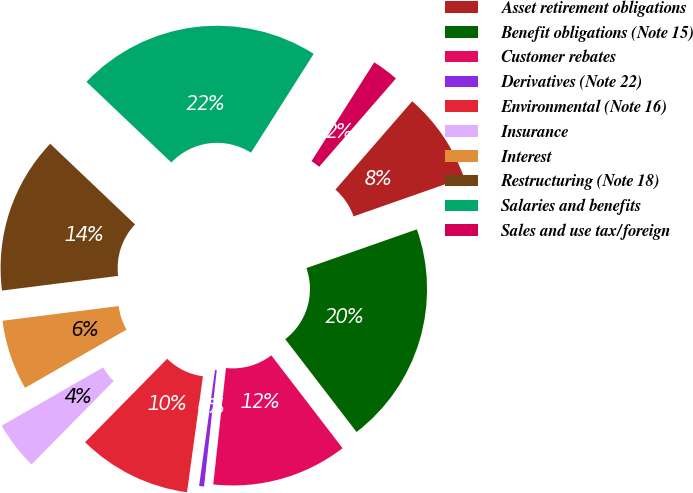Convert chart. <chart><loc_0><loc_0><loc_500><loc_500><pie_chart><fcel>Asset retirement obligations<fcel>Benefit obligations (Note 15)<fcel>Customer rebates<fcel>Derivatives (Note 22)<fcel>Environmental (Note 16)<fcel>Insurance<fcel>Interest<fcel>Restructuring (Note 18)<fcel>Salaries and benefits<fcel>Sales and use tax/foreign<nl><fcel>8.24%<fcel>19.95%<fcel>12.15%<fcel>0.44%<fcel>10.2%<fcel>4.34%<fcel>6.29%<fcel>14.1%<fcel>21.9%<fcel>2.39%<nl></chart> 